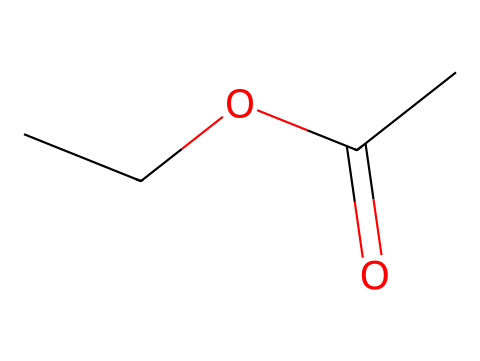What is the name of this chemical? The chemical represented by the SMILES CC(=O)OCC is known as ethyl acetate. This is identified by analyzing the functional groups and structure typical for esters, which include an ester functional group derived from acetic acid and ethanol.
Answer: ethyl acetate How many carbon atoms are in ethyl acetate? By examining the SMILES representation CC(=O)OCC, we can count the carbon atoms: there are 4 carbons in total (two from the ethyl group and one from the acetate group).
Answer: 4 What is the functional group present in ethyl acetate? The chemical contains a carbonyl group (C=O) and an ether group (C-O-C) characteristic of esters. When observing the structure, the carbonyl connections indicate the presence of the ester functional group.
Answer: ester What is the total number of oxygen atoms in ethyl acetate? There are two oxygen atoms present in the structure, one as part of the carbonyl group and one in the ether context, which is deduced logically from the structure revealed in the SMILES representation.
Answer: 2 What type of reaction primarily forms esters like ethyl acetate? Esters are commonly formed through a process called esterification, which typically involves a carboxylic acid and an alcohol reacting together. In this case, acetic acid and ethanol are implicated.
Answer: esterification What is the molecular formula of ethyl acetate? By analyzing the components depicted in the SMILES CC(=O)OCC, the molecular composition can be calculated to be C4H8O2, considering the contribution of the atoms derived from both the acetate and ethyl groups combined.
Answer: C4H8O2 